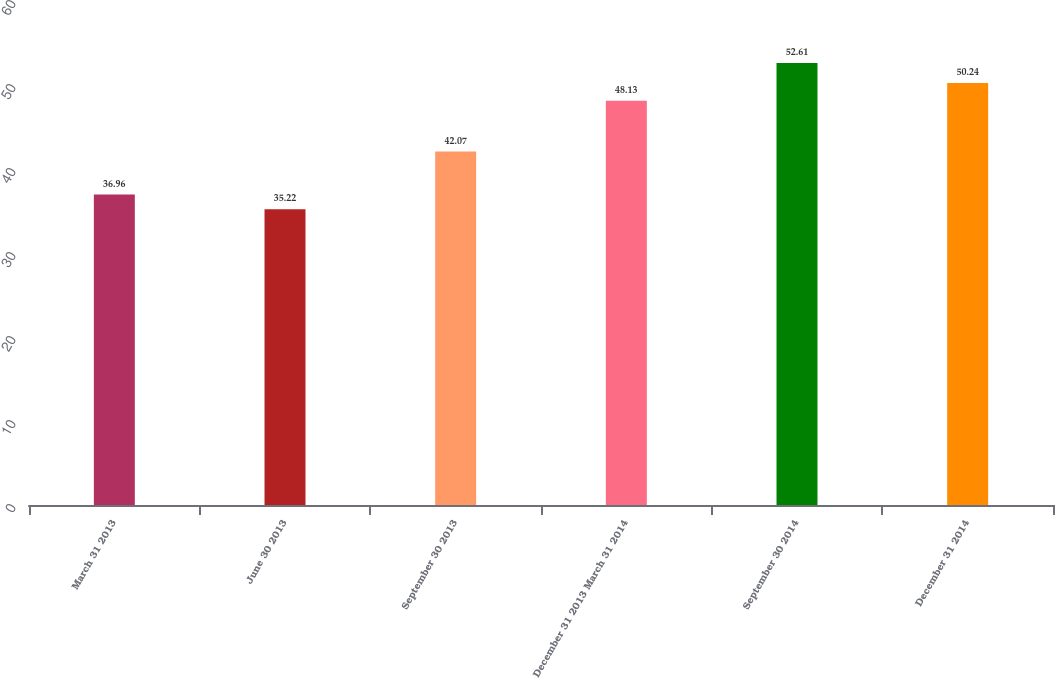Convert chart. <chart><loc_0><loc_0><loc_500><loc_500><bar_chart><fcel>March 31 2013<fcel>June 30 2013<fcel>September 30 2013<fcel>December 31 2013 March 31 2014<fcel>September 30 2014<fcel>December 31 2014<nl><fcel>36.96<fcel>35.22<fcel>42.07<fcel>48.13<fcel>52.61<fcel>50.24<nl></chart> 